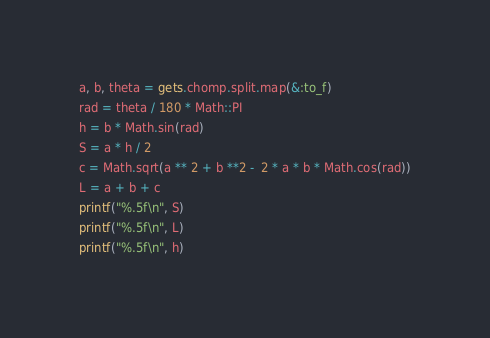<code> <loc_0><loc_0><loc_500><loc_500><_Ruby_>a, b, theta = gets.chomp.split.map(&:to_f)
rad = theta / 180 * Math::PI
h = b * Math.sin(rad)
S = a * h / 2
c = Math.sqrt(a ** 2 + b **2 -  2 * a * b * Math.cos(rad))
L = a + b + c
printf("%.5f\n", S)
printf("%.5f\n", L)
printf("%.5f\n", h)</code> 